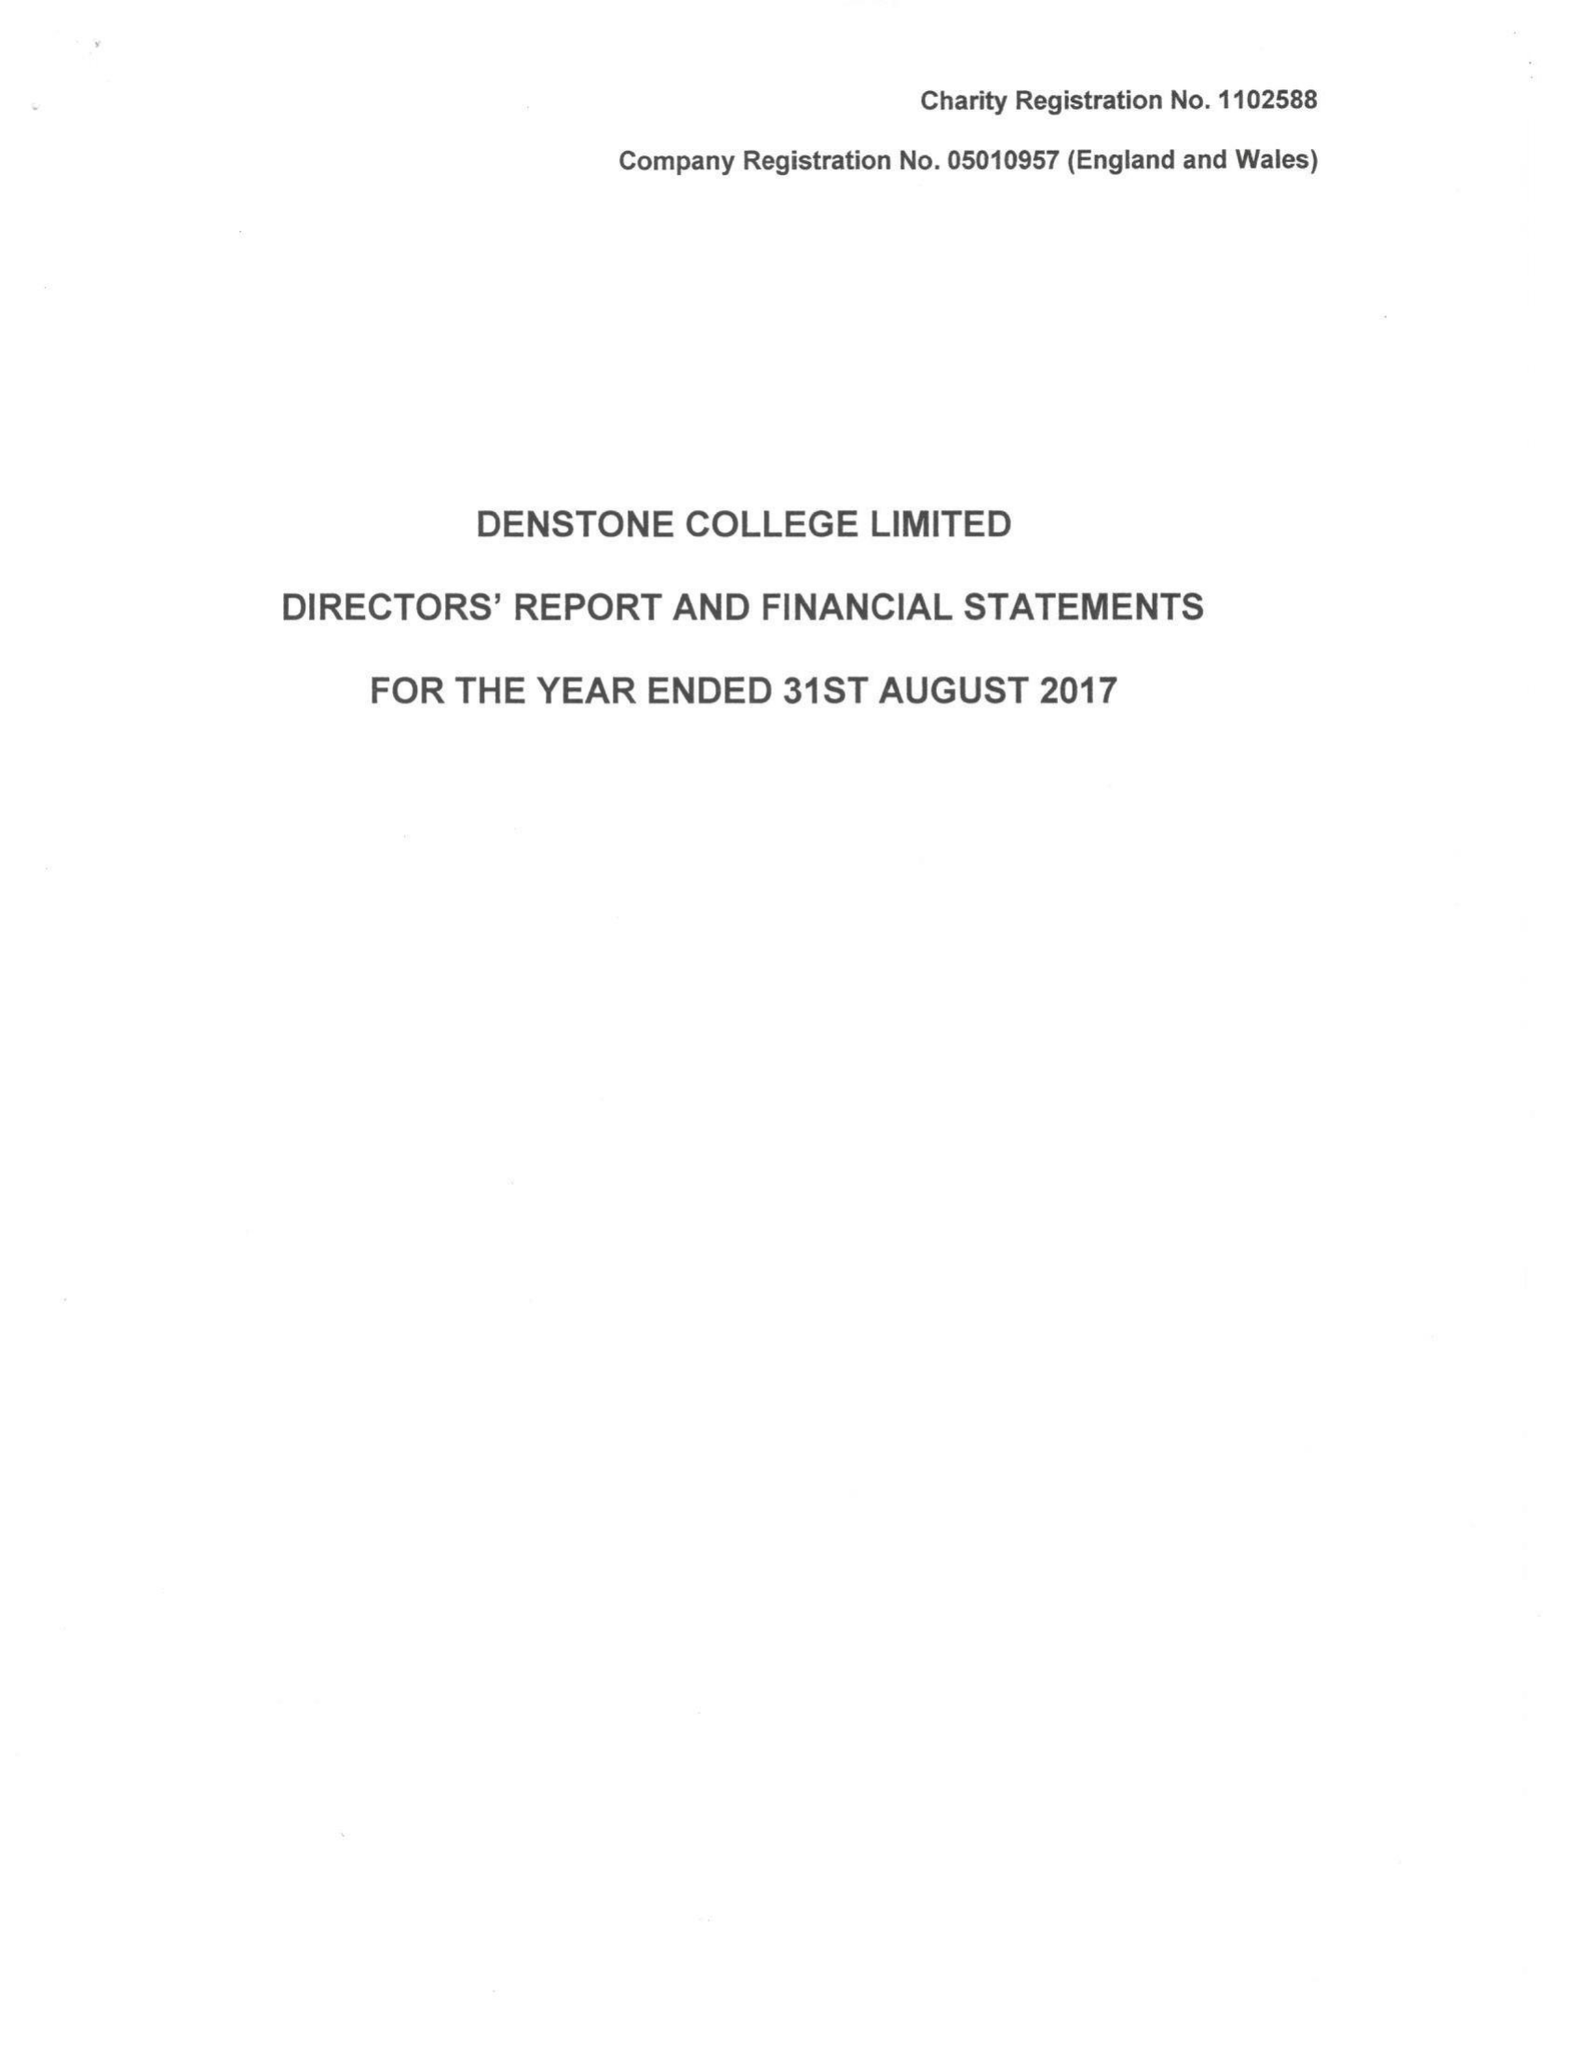What is the value for the address__post_town?
Answer the question using a single word or phrase. UTTOXETER 